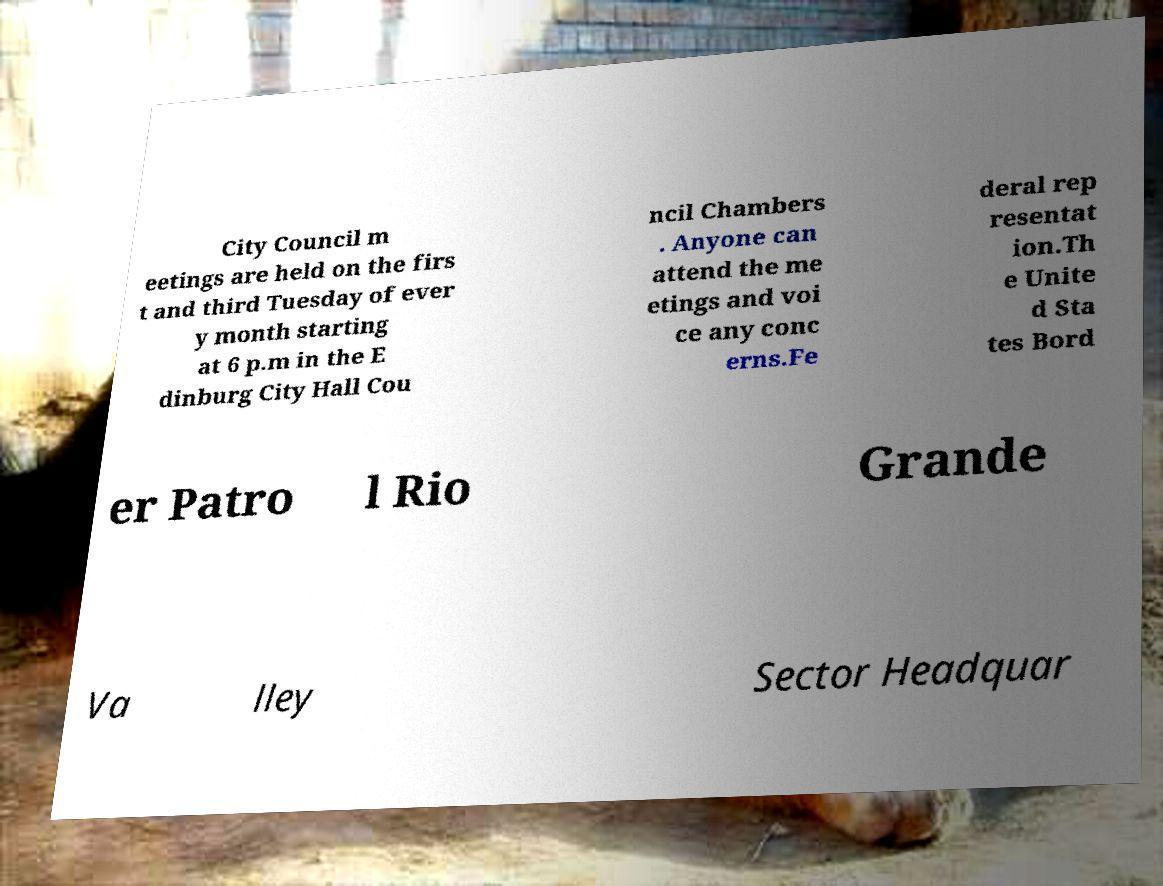For documentation purposes, I need the text within this image transcribed. Could you provide that? City Council m eetings are held on the firs t and third Tuesday of ever y month starting at 6 p.m in the E dinburg City Hall Cou ncil Chambers . Anyone can attend the me etings and voi ce any conc erns.Fe deral rep resentat ion.Th e Unite d Sta tes Bord er Patro l Rio Grande Va lley Sector Headquar 